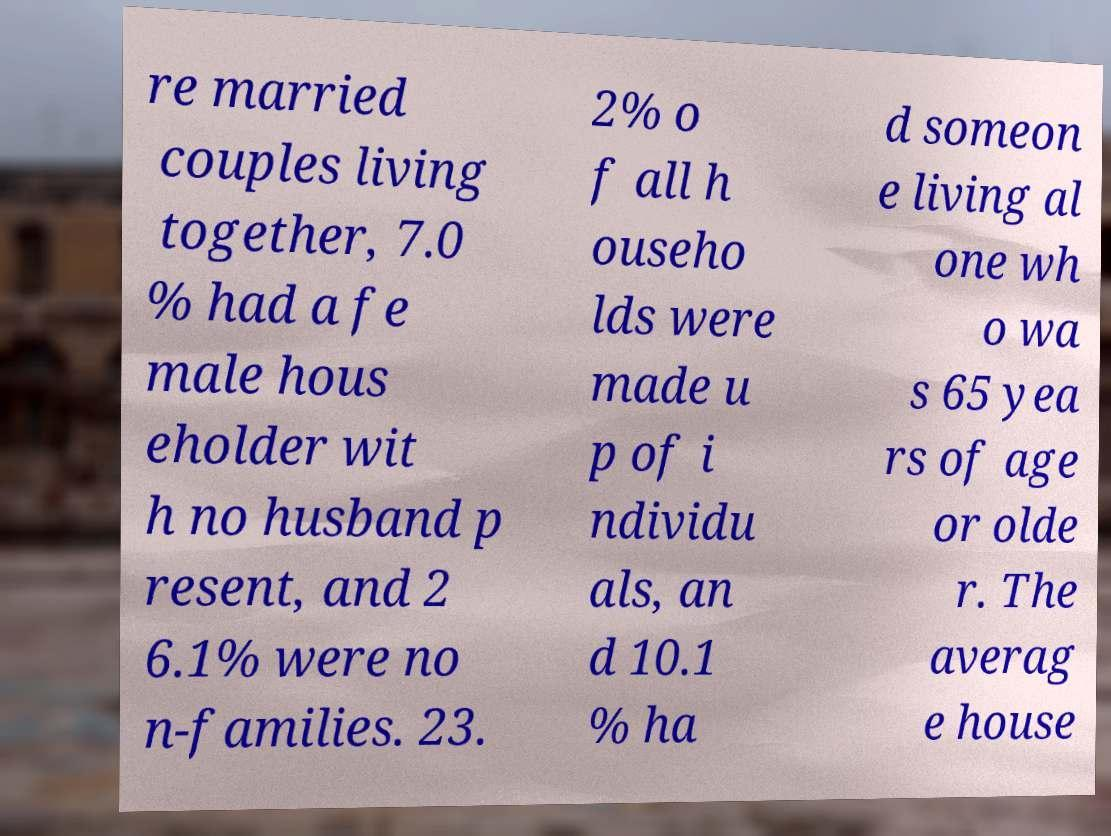Can you read and provide the text displayed in the image?This photo seems to have some interesting text. Can you extract and type it out for me? re married couples living together, 7.0 % had a fe male hous eholder wit h no husband p resent, and 2 6.1% were no n-families. 23. 2% o f all h ouseho lds were made u p of i ndividu als, an d 10.1 % ha d someon e living al one wh o wa s 65 yea rs of age or olde r. The averag e house 